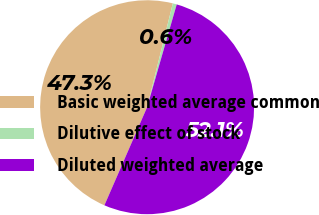Convert chart. <chart><loc_0><loc_0><loc_500><loc_500><pie_chart><fcel>Basic weighted average common<fcel>Dilutive effect of stock<fcel>Diluted weighted average<nl><fcel>47.33%<fcel>0.6%<fcel>52.07%<nl></chart> 